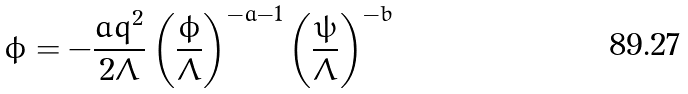<formula> <loc_0><loc_0><loc_500><loc_500>\ddot { \phi } = - \frac { a q ^ { 2 } } { 2 \Lambda } \left ( \frac { \phi } { \Lambda } \right ) ^ { - a - 1 } \left ( \frac { \psi } { \Lambda } \right ) ^ { - b }</formula> 